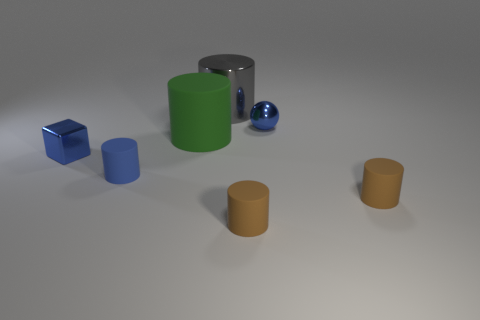Add 1 big green rubber cylinders. How many objects exist? 8 Subtract all spheres. How many objects are left? 6 Subtract 0 yellow spheres. How many objects are left? 7 Subtract all small shiny blocks. Subtract all tiny blue spheres. How many objects are left? 5 Add 1 large gray metallic things. How many large gray metallic things are left? 2 Add 1 small gray metal cylinders. How many small gray metal cylinders exist? 1 